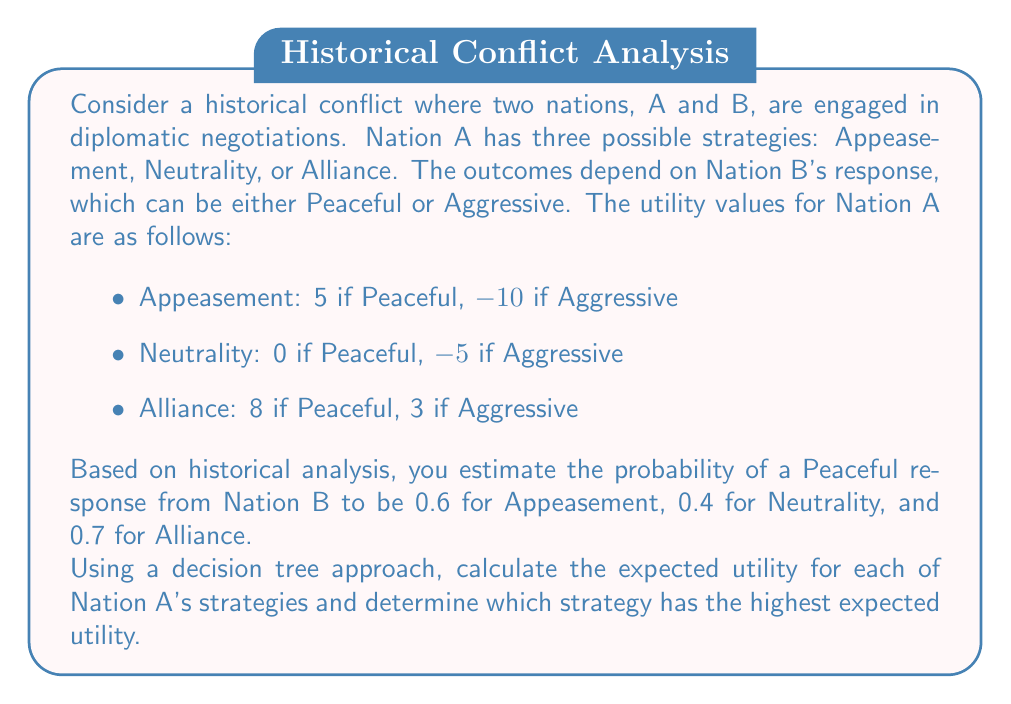Could you help me with this problem? To solve this problem, we'll use a decision tree approach and calculate the expected utility for each strategy:

1. Appeasement Strategy:
   $$E(U_{Appeasement}) = 0.6 \times 5 + 0.4 \times (-10) = 3 - 4 = -1$$

2. Neutrality Strategy:
   $$E(U_{Neutrality}) = 0.4 \times 0 + 0.6 \times (-5) = 0 - 3 = -3$$

3. Alliance Strategy:
   $$E(U_{Alliance}) = 0.7 \times 8 + 0.3 \times 3 = 5.6 + 0.9 = 6.5$$

The decision tree can be represented as follows:

[asy]
import geometry;

pair A = (0,0);
pair B1 = (100,50);
pair B2 = (100,0);
pair B3 = (100,-50);
pair C1 = (200,75);
pair C2 = (200,25);
pair C3 = (200,0);
pair C4 = (200,-25);
pair C5 = (200,-75);
pair C6 = (200,-100);

draw(A--B1--C1);
draw(A--B1--C2);
draw(A--B2--C3);
draw(A--B2--C4);
draw(A--B3--C5);
draw(A--B3--C6);

label("A", A, W);
label("Appeasement", (B1+A)/2, N);
label("Neutrality", (B2+A)/2, E);
label("Alliance", (B3+A)/2, S);
label("Peaceful (0.6)", (C1+B1)/2, N);
label("Aggressive (0.4)", (C2+B1)/2, S);
label("Peaceful (0.4)", (C3+B2)/2, N);
label("Aggressive (0.6)", (C4+B2)/2, S);
label("Peaceful (0.7)", (C5+B3)/2, N);
label("Aggressive (0.3)", (C6+B3)/2, S);
label("5", C1, E);
label("-10", C2, E);
label("0", C3, E);
label("-5", C4, E);
label("8", C5, E);
label("3", C6, E);
[/asy]

To determine which strategy has the highest expected utility, we compare the calculated values:

- Appeasement: -1
- Neutrality: -3
- Alliance: 6.5

The strategy with the highest expected utility is Alliance, with an expected utility of 6.5.
Answer: The strategy with the highest expected utility is Alliance, with an expected utility of 6.5. 